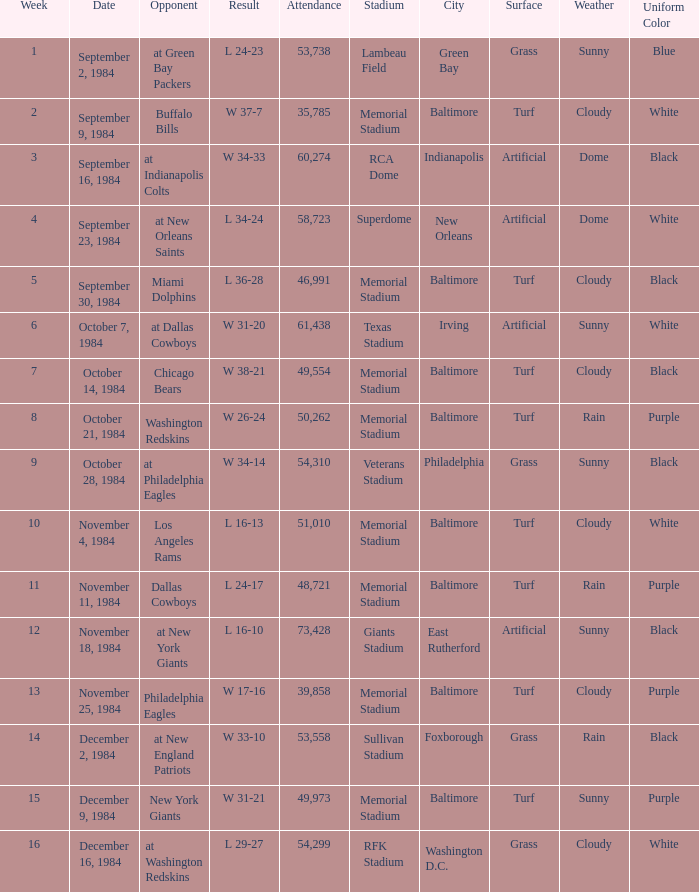What was the result in a week lower than 10 with an opponent of Chicago Bears? W 38-21. 